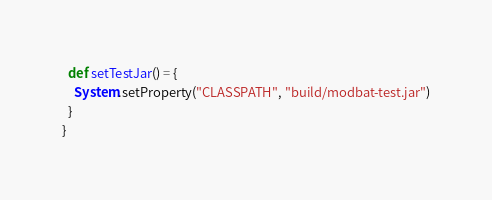<code> <loc_0><loc_0><loc_500><loc_500><_Scala_>
  def setTestJar() = {
    System.setProperty("CLASSPATH", "build/modbat-test.jar")
  }
}

</code> 